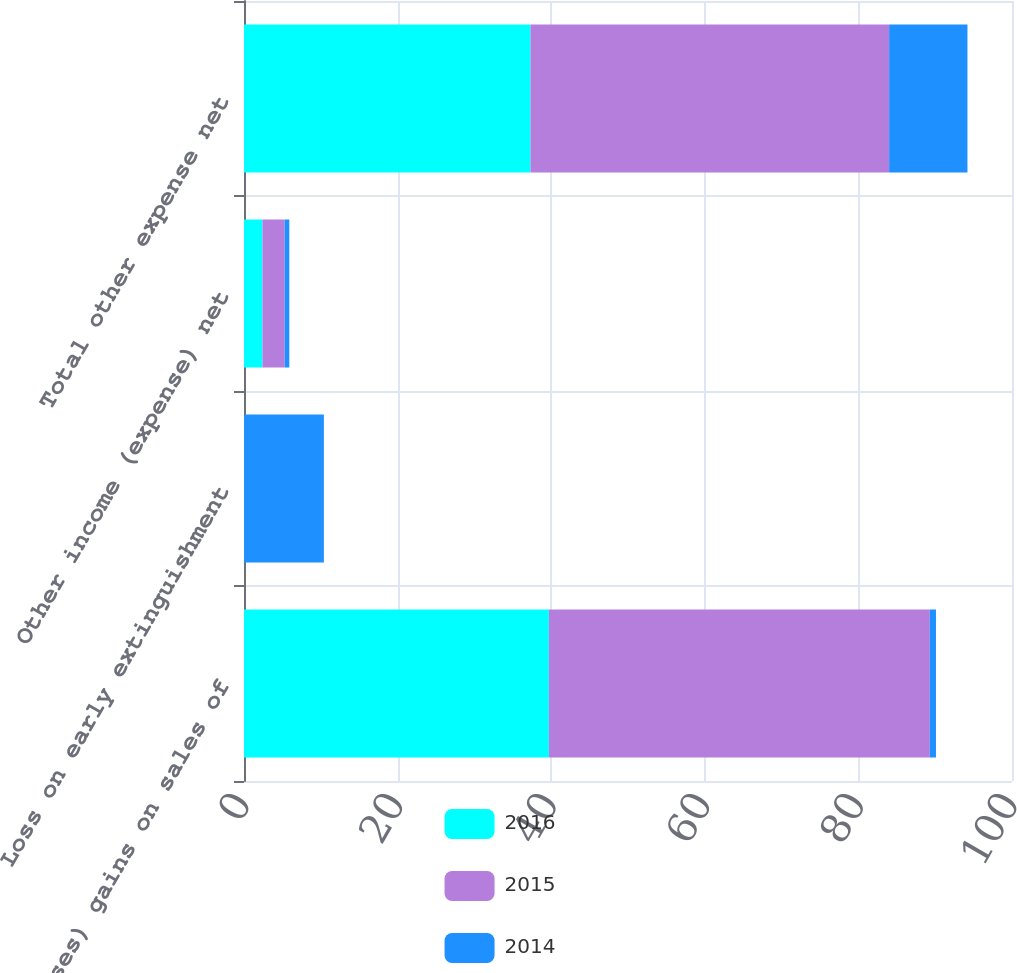Convert chart. <chart><loc_0><loc_0><loc_500><loc_500><stacked_bar_chart><ecel><fcel>(Losses) gains on sales of<fcel>Loss on early extinguishment<fcel>Other income (expense) net<fcel>Total other expense net<nl><fcel>2016<fcel>39.7<fcel>0<fcel>2.4<fcel>37.3<nl><fcel>2015<fcel>49.6<fcel>0<fcel>2.9<fcel>46.7<nl><fcel>2014<fcel>0.8<fcel>10.4<fcel>0.6<fcel>10.2<nl></chart> 